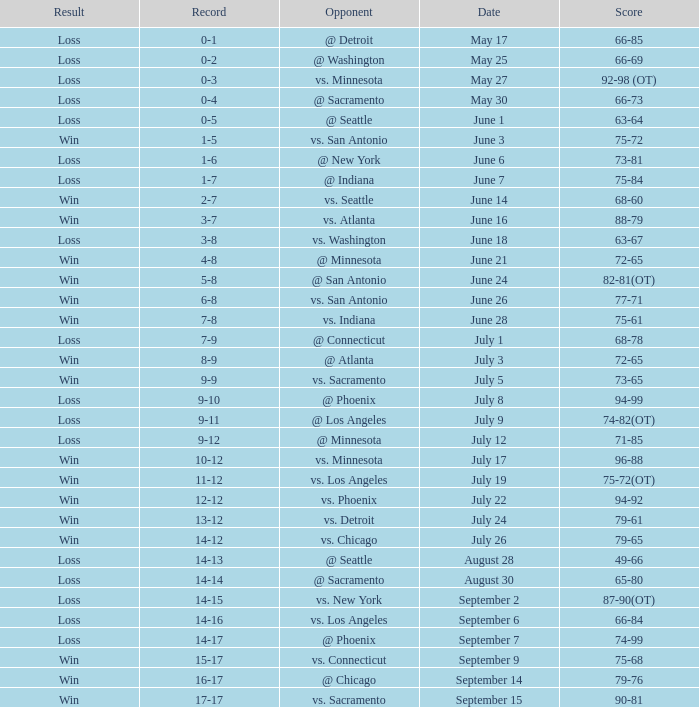What is the Record of the game on June 24? 5-8. 